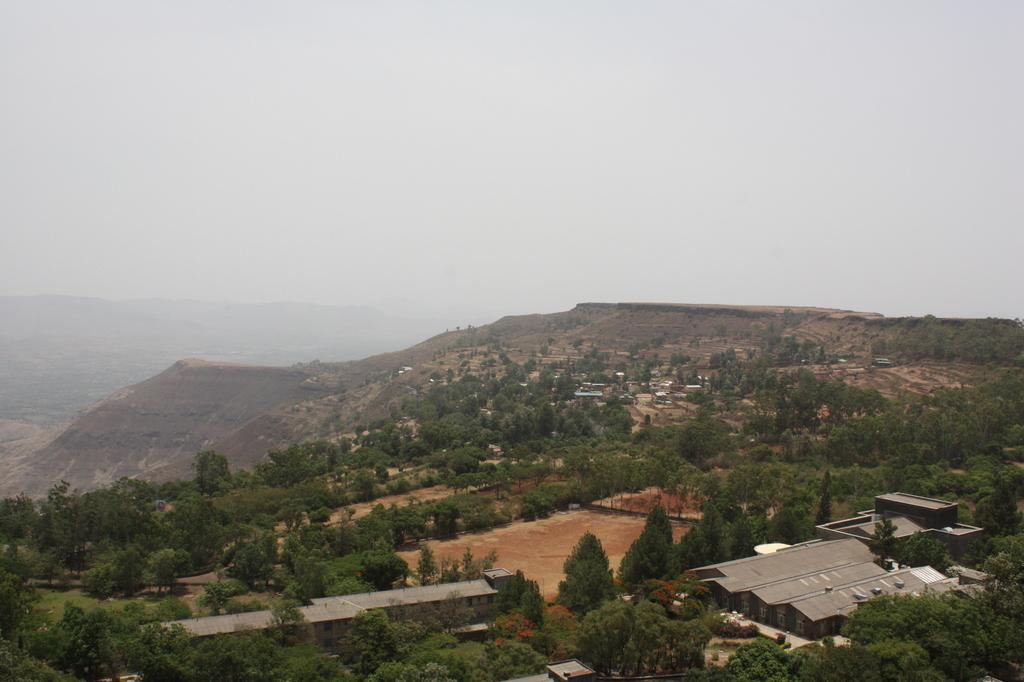Can you describe this image briefly? In the image we can see the building, trees, mountains and the sky. 